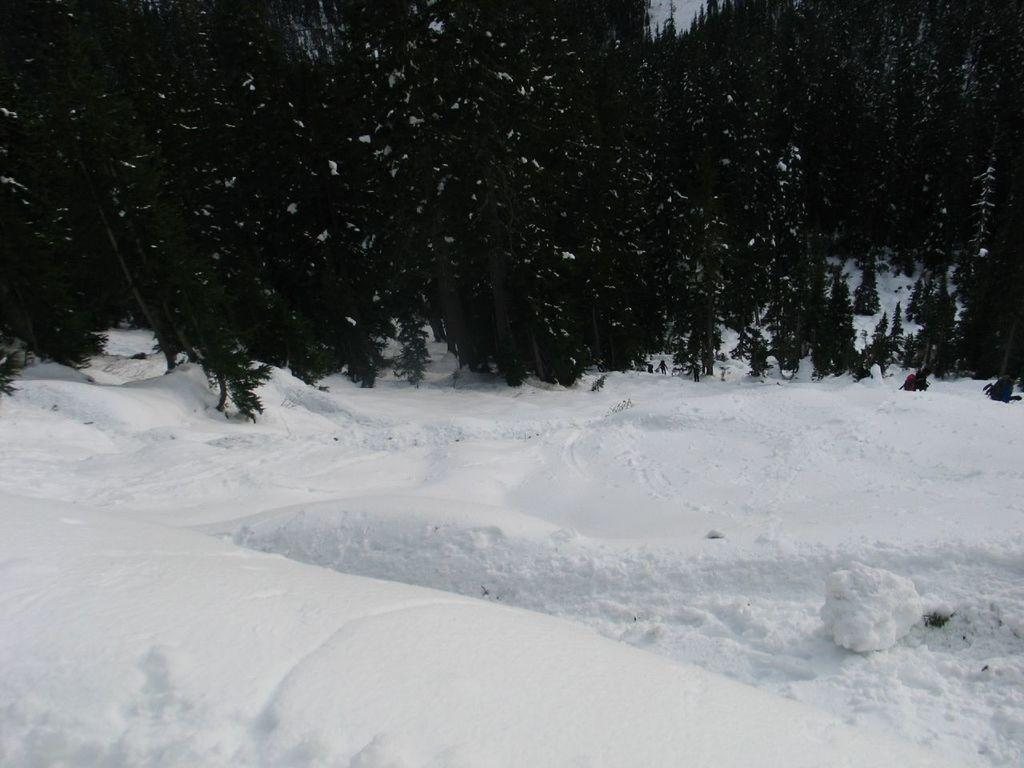What is the primary feature of the image? There is snow in the image. What can be seen in the background of the image? There are trees in the background of the image. What type of net is being used by the father in the image? There is no father or net present in the image; it only features snow and trees. 